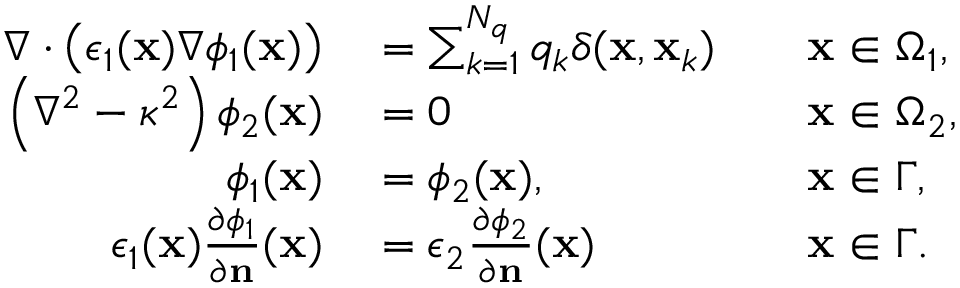<formula> <loc_0><loc_0><loc_500><loc_500>\begin{array} { r l r l } { \nabla \cdot \left ( \epsilon _ { 1 } ( x ) \nabla \phi _ { 1 } ( x ) \right ) } & = \sum _ { k = 1 } ^ { N _ { q } } q _ { k } \delta ( x , x _ { k } ) } & x \in \Omega _ { 1 } , } \\ { \left ( \nabla ^ { 2 } - \kappa ^ { 2 } \right ) \phi _ { 2 } ( x ) } & = 0 } & x \in \Omega _ { 2 } , } \\ { \phi _ { 1 } ( x ) } & = \phi _ { 2 } ( x ) , } & x \in \Gamma , } \\ { \epsilon _ { 1 } ( x ) \frac { \partial \phi _ { 1 } } { \partial n } ( x ) } & = \epsilon _ { 2 } \frac { \partial \phi _ { 2 } } { \partial n } ( x ) } & x \in \Gamma . } \end{array}</formula> 